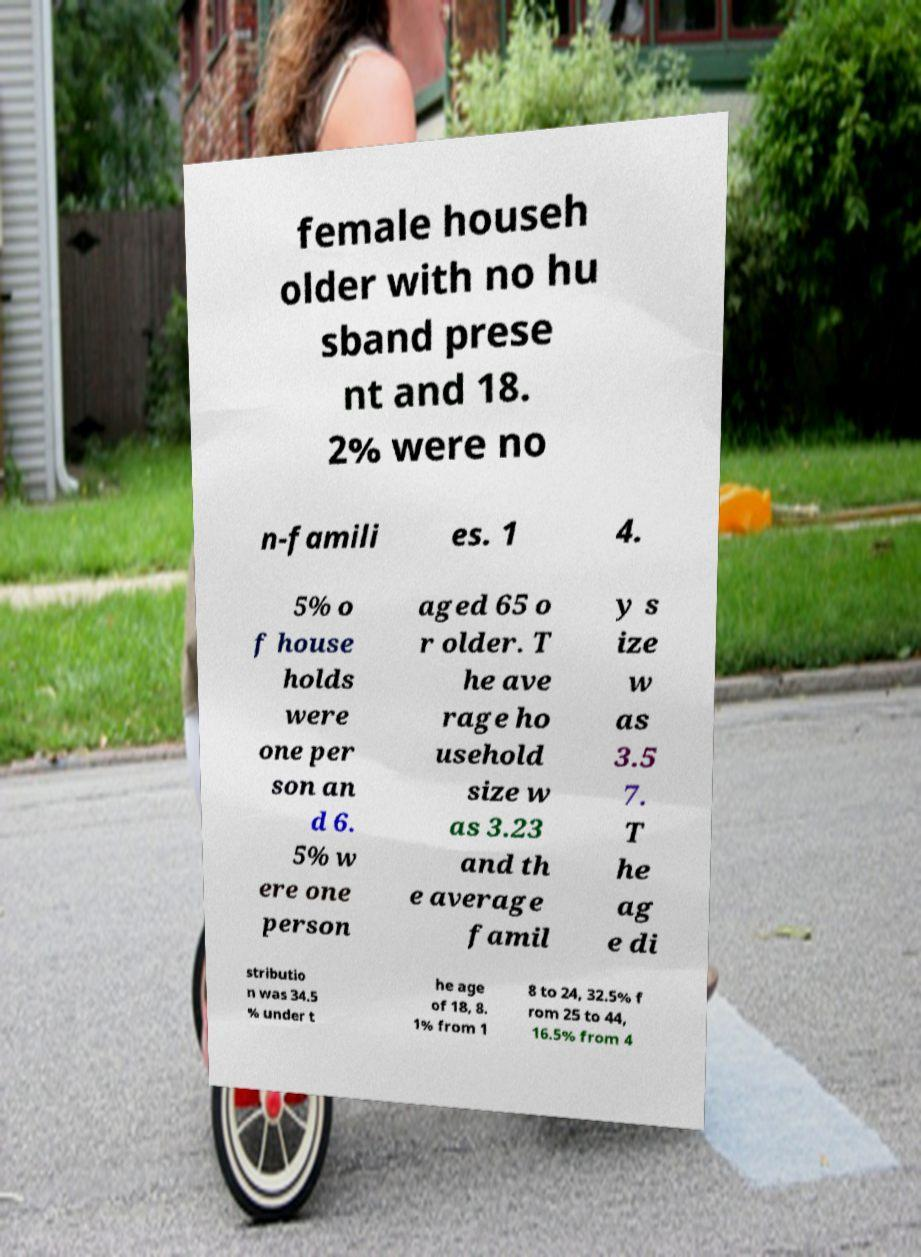Could you extract and type out the text from this image? female househ older with no hu sband prese nt and 18. 2% were no n-famili es. 1 4. 5% o f house holds were one per son an d 6. 5% w ere one person aged 65 o r older. T he ave rage ho usehold size w as 3.23 and th e average famil y s ize w as 3.5 7. T he ag e di stributio n was 34.5 % under t he age of 18, 8. 1% from 1 8 to 24, 32.5% f rom 25 to 44, 16.5% from 4 